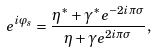Convert formula to latex. <formula><loc_0><loc_0><loc_500><loc_500>e ^ { i \varphi _ { s } } = \frac { \eta ^ { \ast } + \gamma ^ { \ast } e ^ { - 2 i \pi \sigma } } { \eta + \gamma e ^ { 2 i \pi \sigma } } ,</formula> 